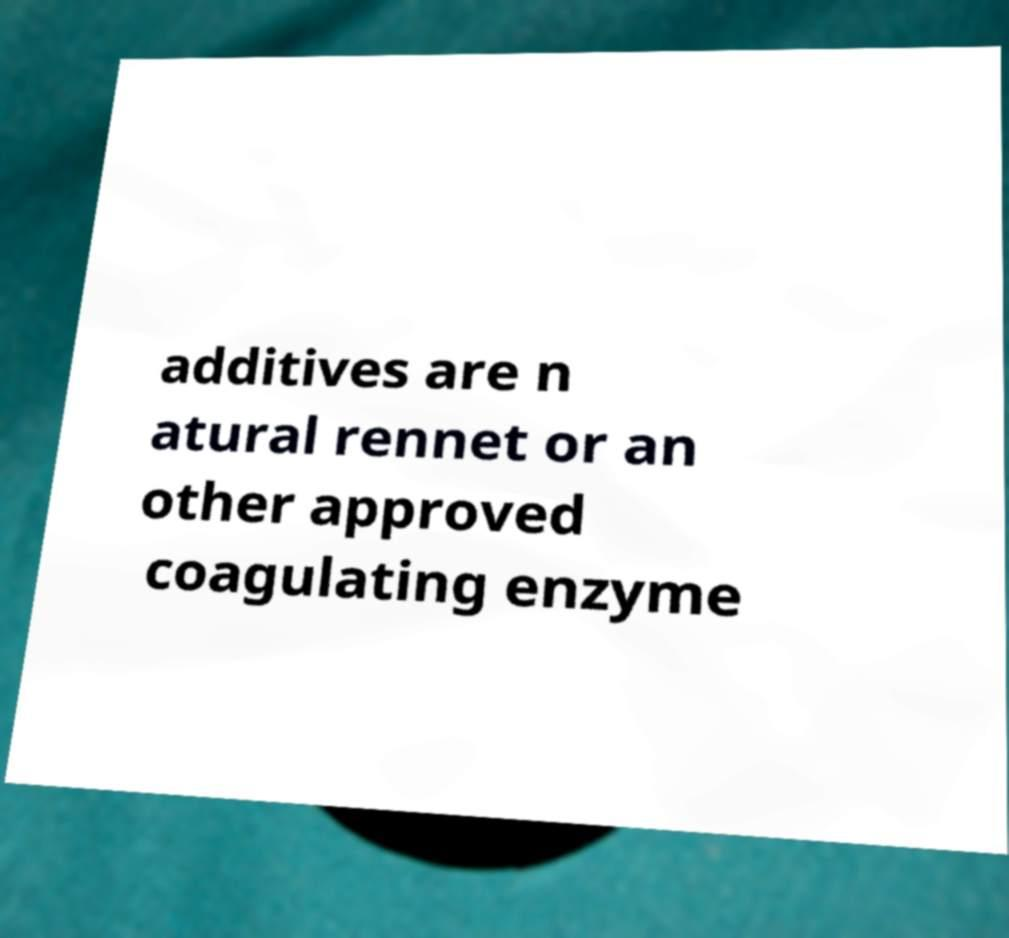Could you extract and type out the text from this image? additives are n atural rennet or an other approved coagulating enzyme 